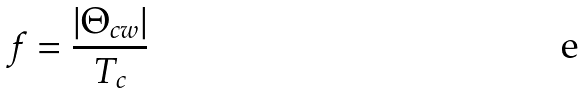Convert formula to latex. <formula><loc_0><loc_0><loc_500><loc_500>f = \frac { | \Theta _ { c w } | } { T _ { c } }</formula> 